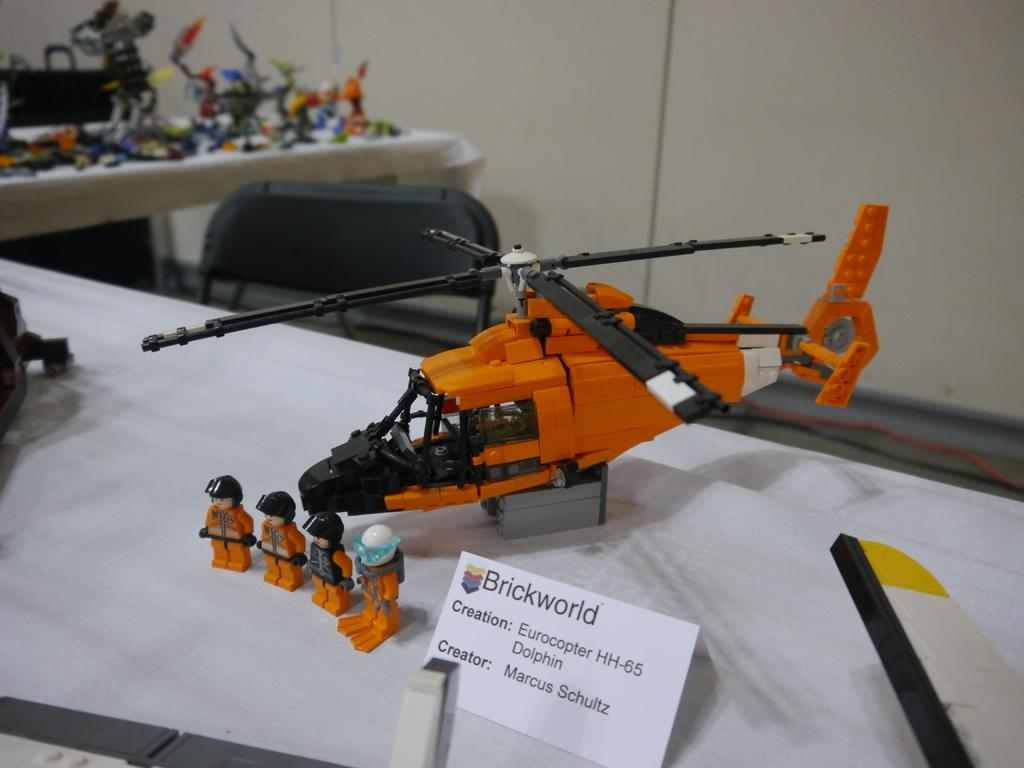<image>
Render a clear and concise summary of the photo. A model helicopiter on table with a card that says Brickworld. 